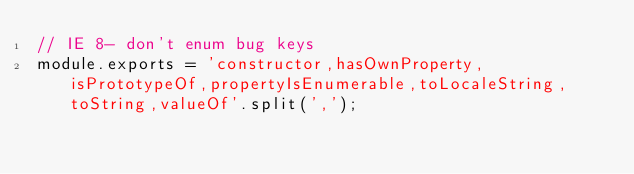Convert code to text. <code><loc_0><loc_0><loc_500><loc_500><_JavaScript_>// IE 8- don't enum bug keys
module.exports = 'constructor,hasOwnProperty,isPrototypeOf,propertyIsEnumerable,toLocaleString,toString,valueOf'.split(',');</code> 